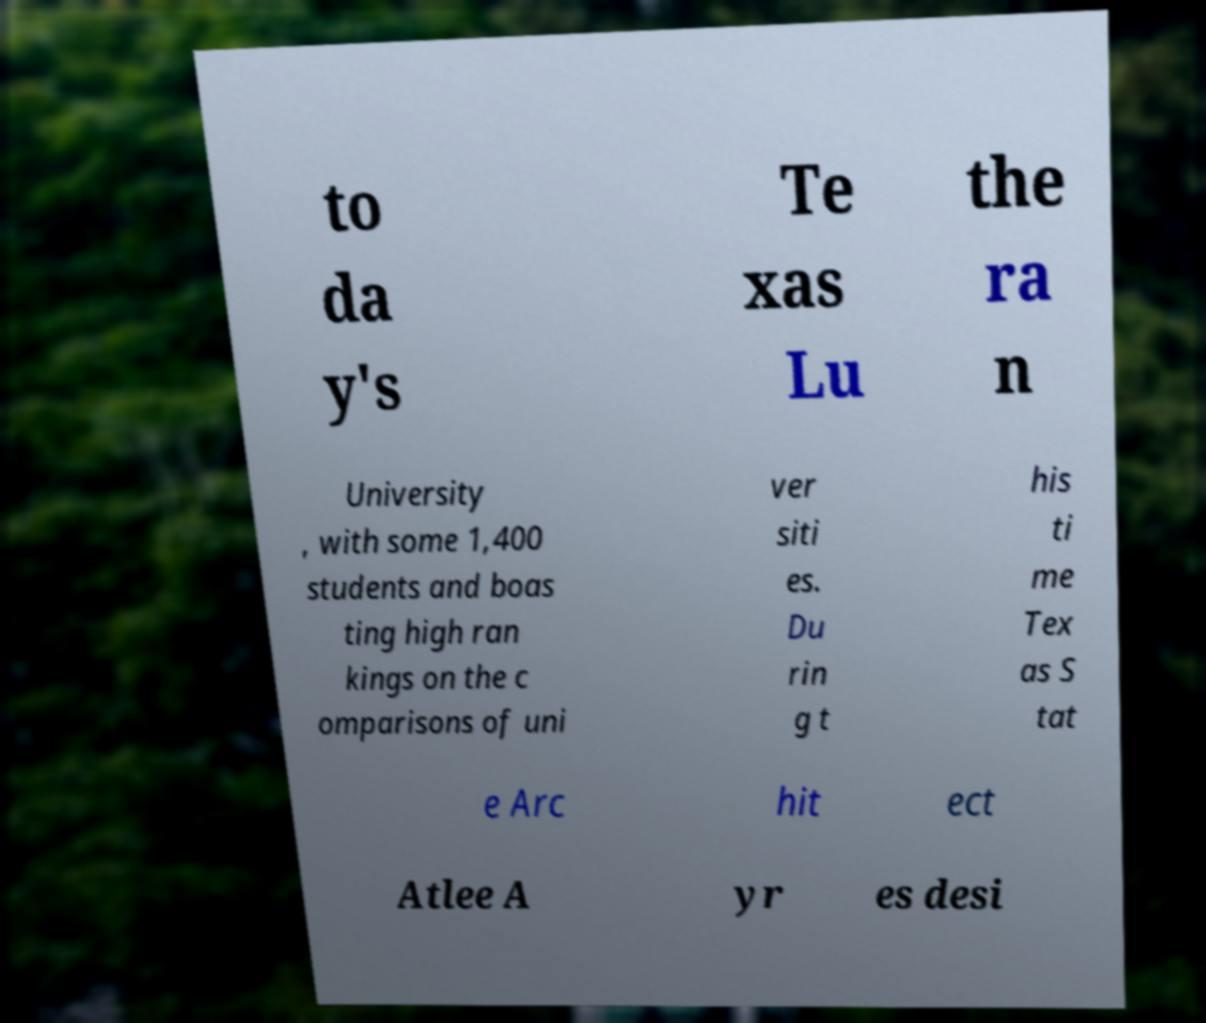Can you accurately transcribe the text from the provided image for me? to da y's Te xas Lu the ra n University , with some 1,400 students and boas ting high ran kings on the c omparisons of uni ver siti es. Du rin g t his ti me Tex as S tat e Arc hit ect Atlee A yr es desi 